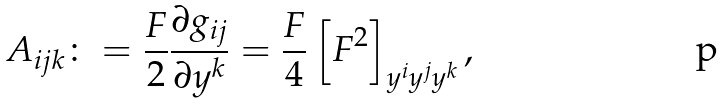<formula> <loc_0><loc_0><loc_500><loc_500>A _ { i j k } \colon = \frac { F } { 2 } \frac { \partial g _ { i j } } { \partial y ^ { k } } = \frac { F } { 4 } \left [ F ^ { 2 } \right ] _ { y ^ { i } y ^ { j } y ^ { k } } ,</formula> 